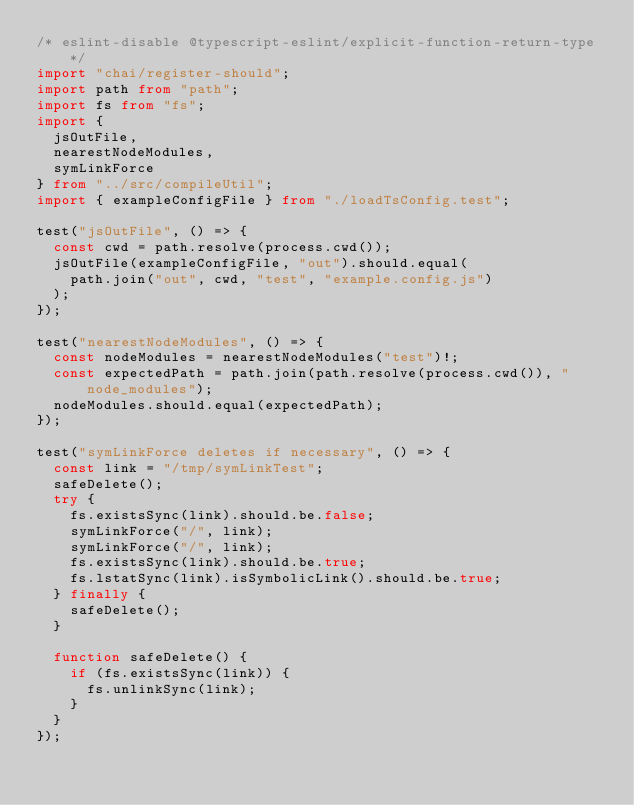Convert code to text. <code><loc_0><loc_0><loc_500><loc_500><_TypeScript_>/* eslint-disable @typescript-eslint/explicit-function-return-type */
import "chai/register-should";
import path from "path";
import fs from "fs";
import {
  jsOutFile,
  nearestNodeModules,
  symLinkForce
} from "../src/compileUtil";
import { exampleConfigFile } from "./loadTsConfig.test";

test("jsOutFile", () => {
  const cwd = path.resolve(process.cwd());
  jsOutFile(exampleConfigFile, "out").should.equal(
    path.join("out", cwd, "test", "example.config.js")
  );
});

test("nearestNodeModules", () => {
  const nodeModules = nearestNodeModules("test")!;
  const expectedPath = path.join(path.resolve(process.cwd()), "node_modules");
  nodeModules.should.equal(expectedPath);
});

test("symLinkForce deletes if necessary", () => {
  const link = "/tmp/symLinkTest";
  safeDelete();
  try {
    fs.existsSync(link).should.be.false;
    symLinkForce("/", link);
    symLinkForce("/", link);
    fs.existsSync(link).should.be.true;
    fs.lstatSync(link).isSymbolicLink().should.be.true;
  } finally {
    safeDelete();
  }

  function safeDelete() {
    if (fs.existsSync(link)) {
      fs.unlinkSync(link);
    }
  }
});
</code> 